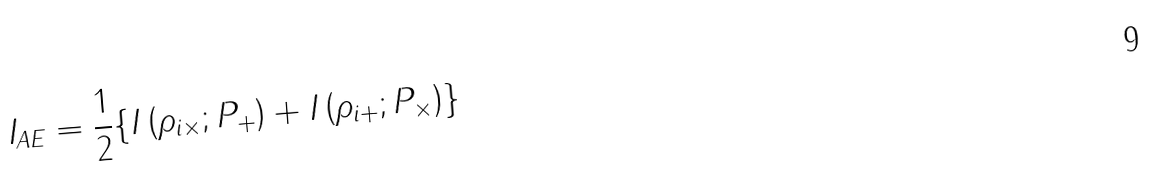<formula> <loc_0><loc_0><loc_500><loc_500>I _ { A E } = \frac { 1 } { 2 } \{ I \left ( \rho _ { i \times } ; P _ { + } \right ) + I \left ( \rho _ { i + } ; P _ { \times } \right ) \}</formula> 